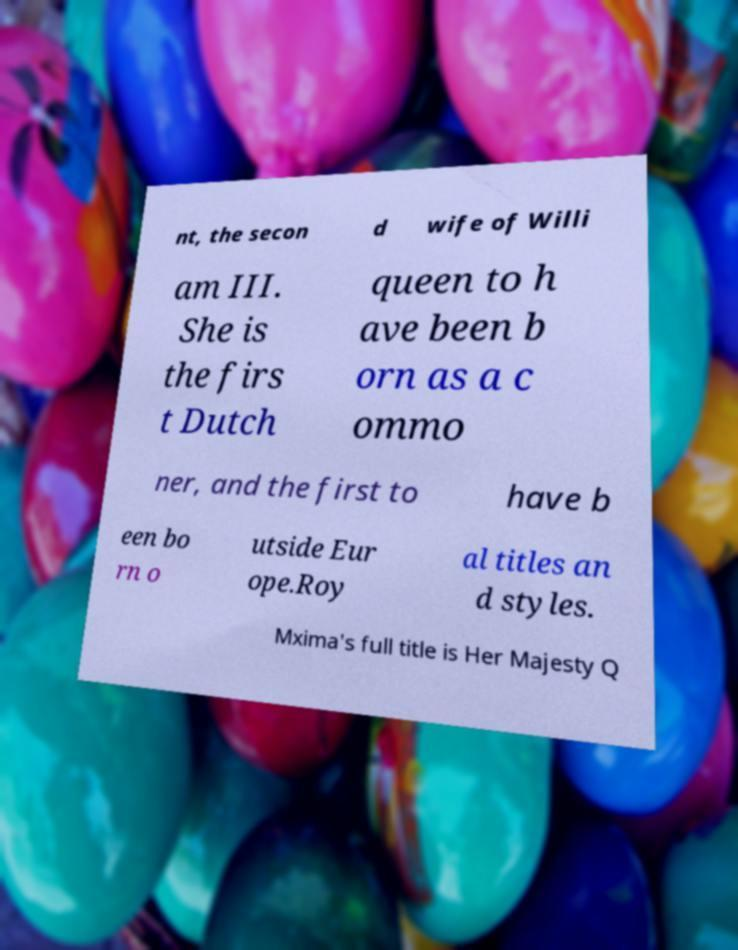Can you accurately transcribe the text from the provided image for me? nt, the secon d wife of Willi am III. She is the firs t Dutch queen to h ave been b orn as a c ommo ner, and the first to have b een bo rn o utside Eur ope.Roy al titles an d styles. Mxima's full title is Her Majesty Q 